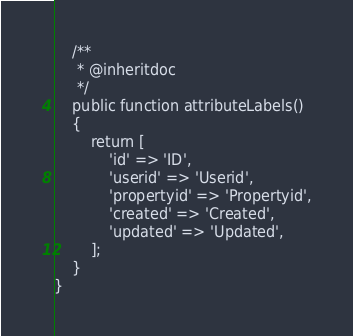Convert code to text. <code><loc_0><loc_0><loc_500><loc_500><_PHP_>
    /**
     * @inheritdoc
     */
    public function attributeLabels()
    {
        return [
            'id' => 'ID',
            'userid' => 'Userid',
            'propertyid' => 'Propertyid',
            'created' => 'Created',
            'updated' => 'Updated',
        ];
    }
}
</code> 